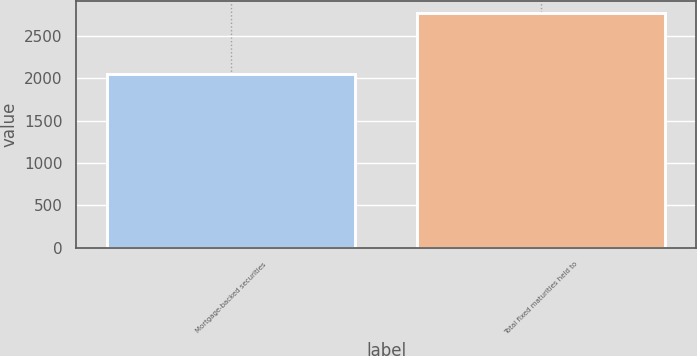Convert chart. <chart><loc_0><loc_0><loc_500><loc_500><bar_chart><fcel>Mortgage-backed securities<fcel>Total fixed maturities held to<nl><fcel>2048<fcel>2765<nl></chart> 